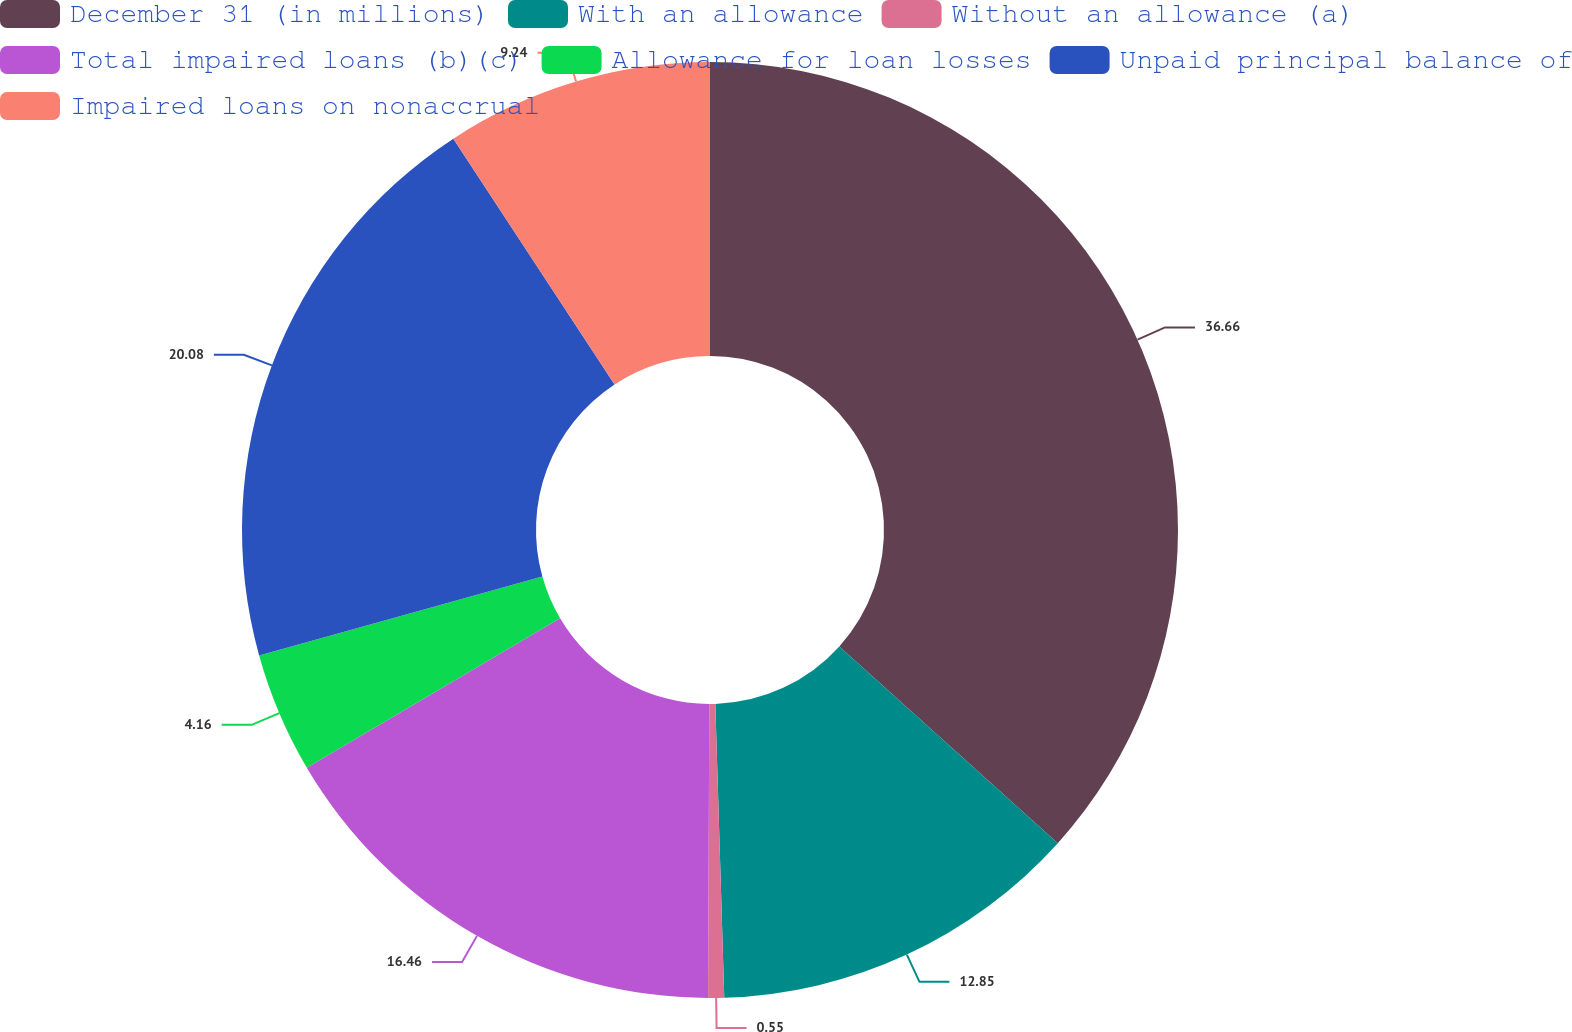<chart> <loc_0><loc_0><loc_500><loc_500><pie_chart><fcel>December 31 (in millions)<fcel>With an allowance<fcel>Without an allowance (a)<fcel>Total impaired loans (b)(c)<fcel>Allowance for loan losses<fcel>Unpaid principal balance of<fcel>Impaired loans on nonaccrual<nl><fcel>36.67%<fcel>12.85%<fcel>0.55%<fcel>16.46%<fcel>4.16%<fcel>20.08%<fcel>9.24%<nl></chart> 